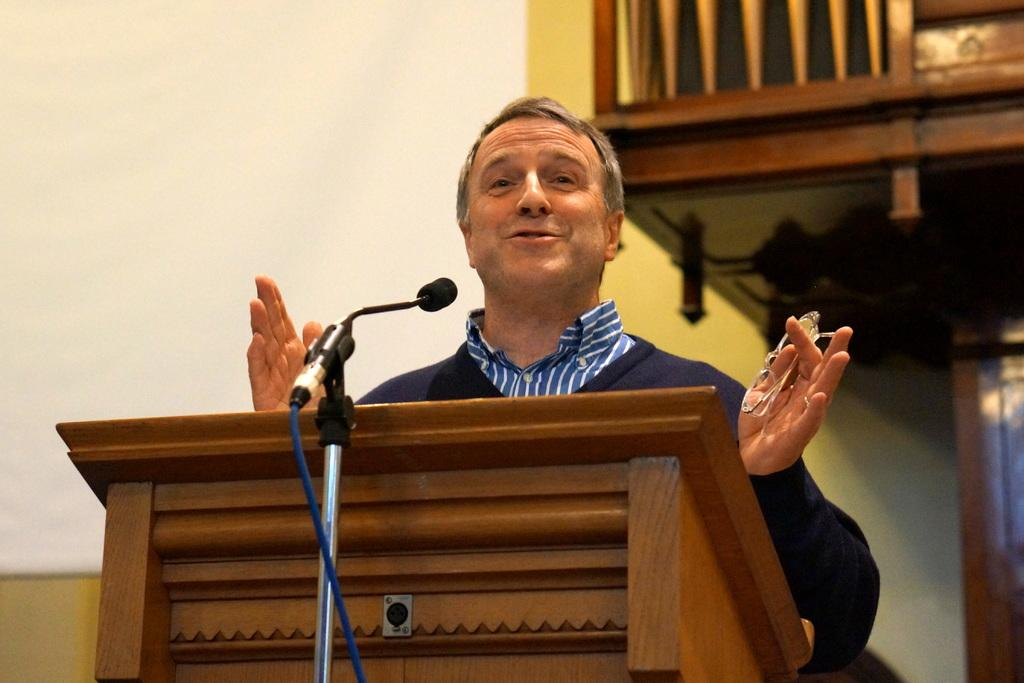Who is the main subject in the image? There is a person in the image. What is the person doing in the image? The person is standing in front of a table and speaking into a microphone. What is the person holding in the image? The person is holding glasses. What can be seen in the background of the image? There are shelves visible in the background of the image. What type of squirrel can be seen sitting on the desk in the image? There is no squirrel present in the image, and there is no desk mentioned in the facts. 